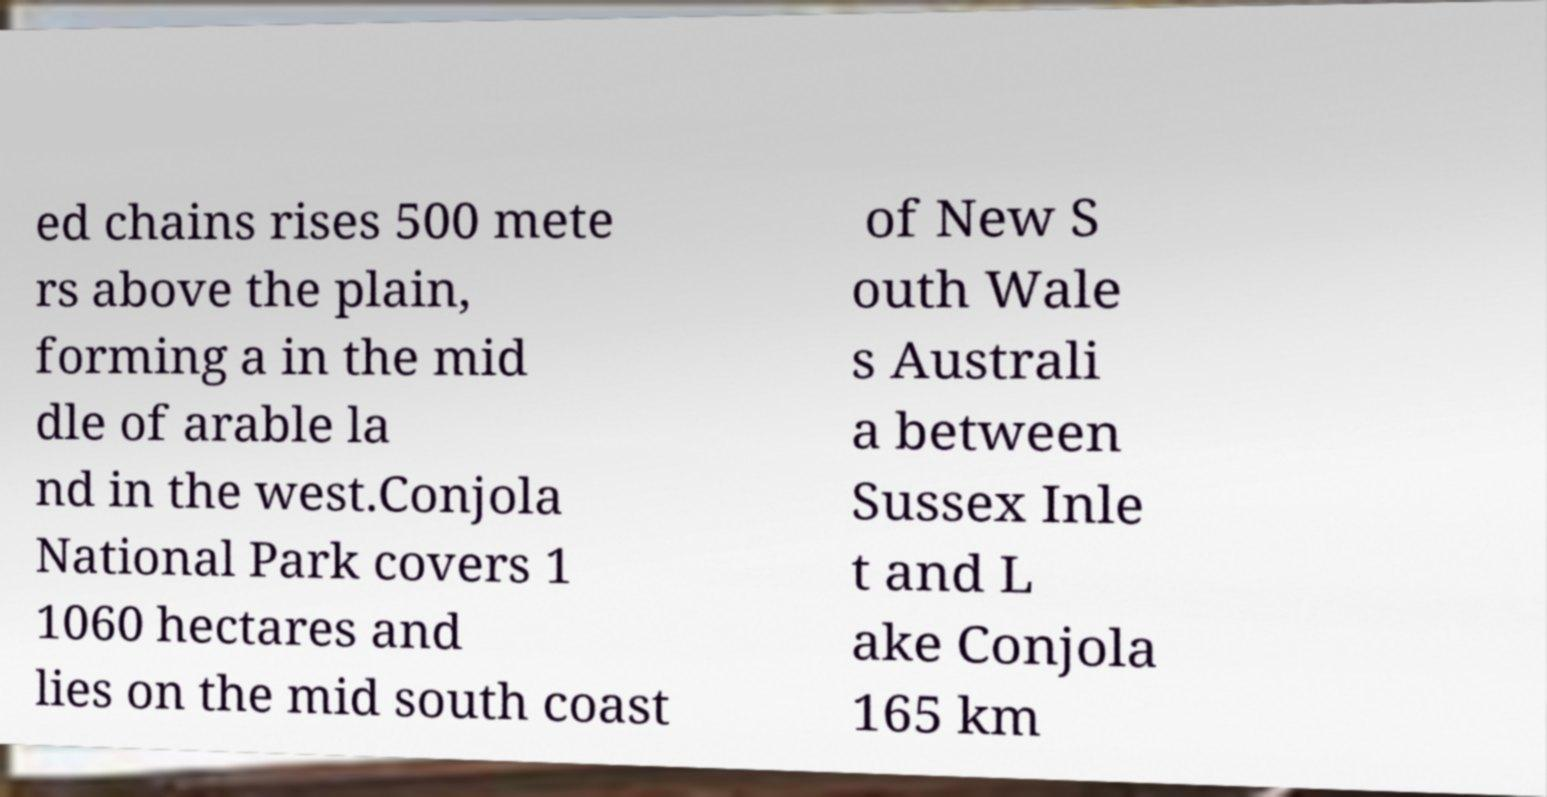Please read and relay the text visible in this image. What does it say? ed chains rises 500 mete rs above the plain, forming a in the mid dle of arable la nd in the west.Conjola National Park covers 1 1060 hectares and lies on the mid south coast of New S outh Wale s Australi a between Sussex Inle t and L ake Conjola 165 km 